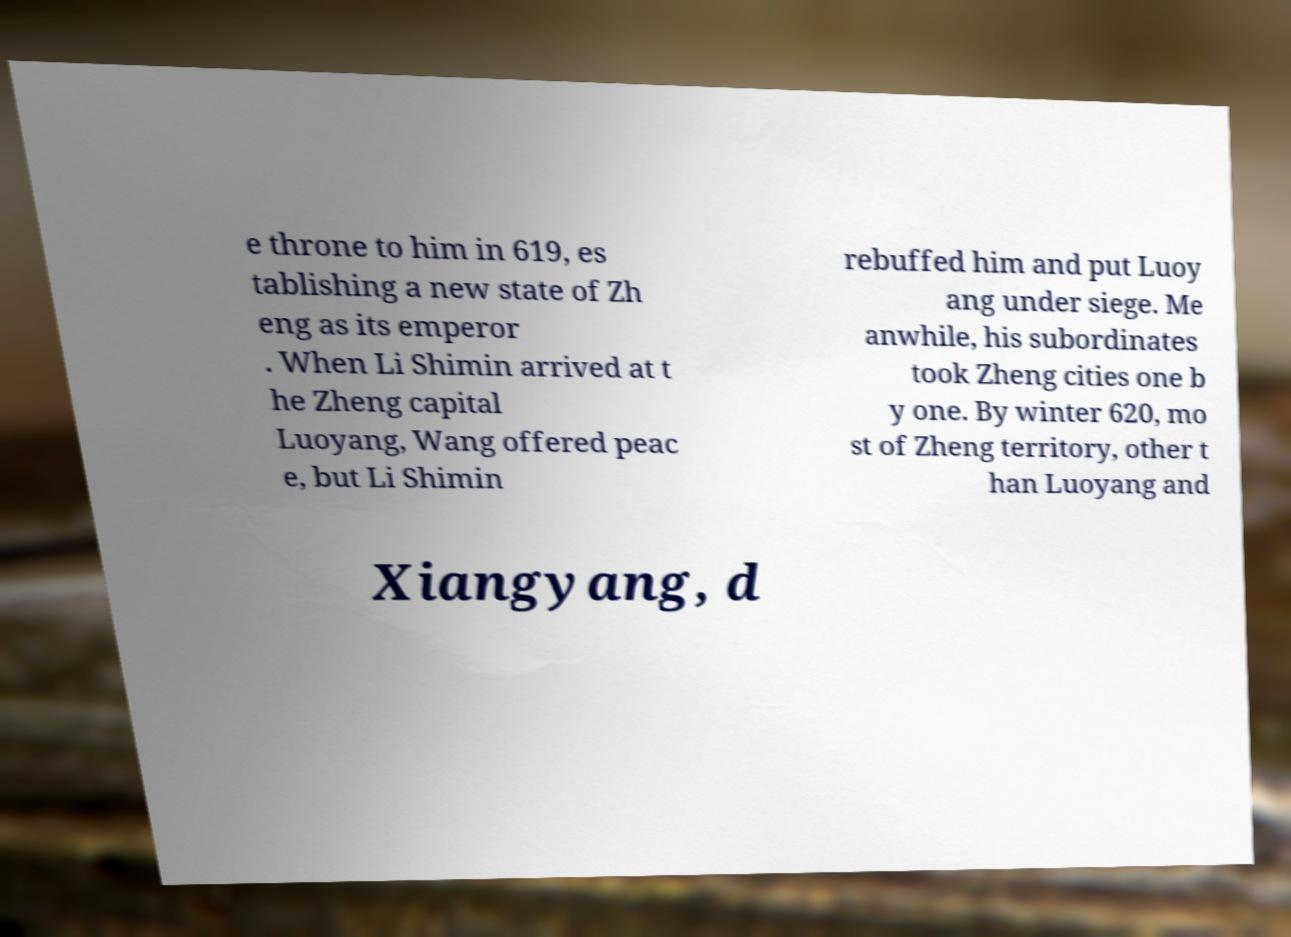What messages or text are displayed in this image? I need them in a readable, typed format. e throne to him in 619, es tablishing a new state of Zh eng as its emperor . When Li Shimin arrived at t he Zheng capital Luoyang, Wang offered peac e, but Li Shimin rebuffed him and put Luoy ang under siege. Me anwhile, his subordinates took Zheng cities one b y one. By winter 620, mo st of Zheng territory, other t han Luoyang and Xiangyang, d 